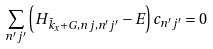<formula> <loc_0><loc_0><loc_500><loc_500>\sum _ { n ^ { \prime } j ^ { \prime } } \left ( H _ { \bar { k } _ { x } + G , n j , n ^ { \prime } j ^ { \prime } } - E \right ) c _ { n ^ { \prime } j ^ { \prime } } = 0</formula> 